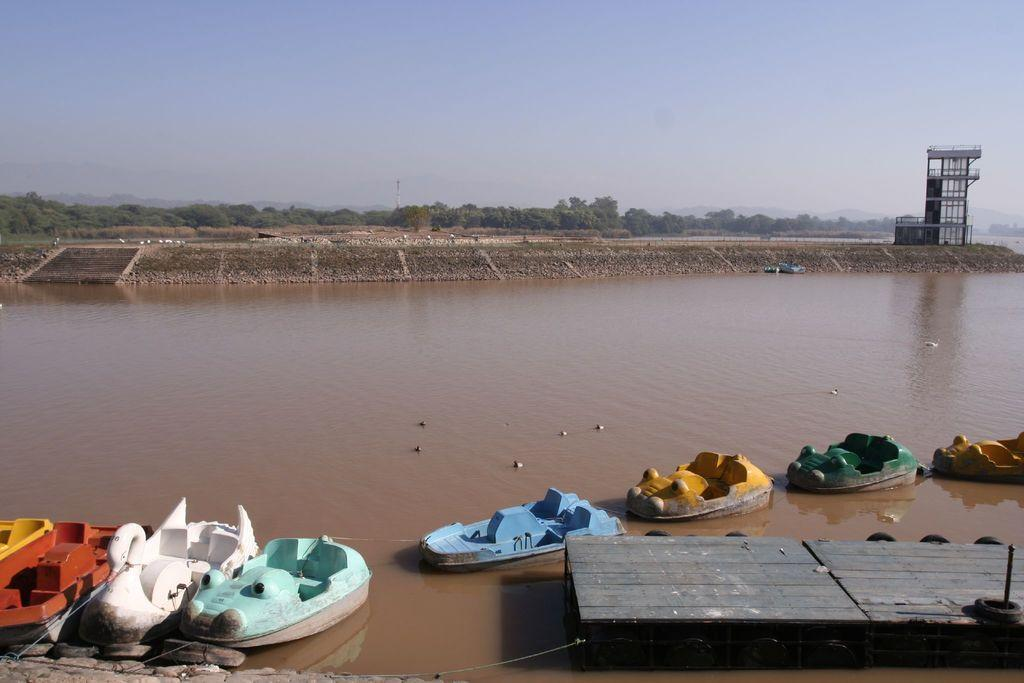What type of water body is present in the image? There is a river in the image. What is on the river in the image? There are boats on the river. What can be seen on the right side of the image? There is a boardwalk on the right side of the image. What structures are visible in the background of the image? There is a tower and trees in the background of the image. What is visible at the top of the image? The sky is visible in the background of the image. What type of silk material is draped over the tower in the image? There is no silk material present in the image; the tower is a structure without any fabric draped over it. 